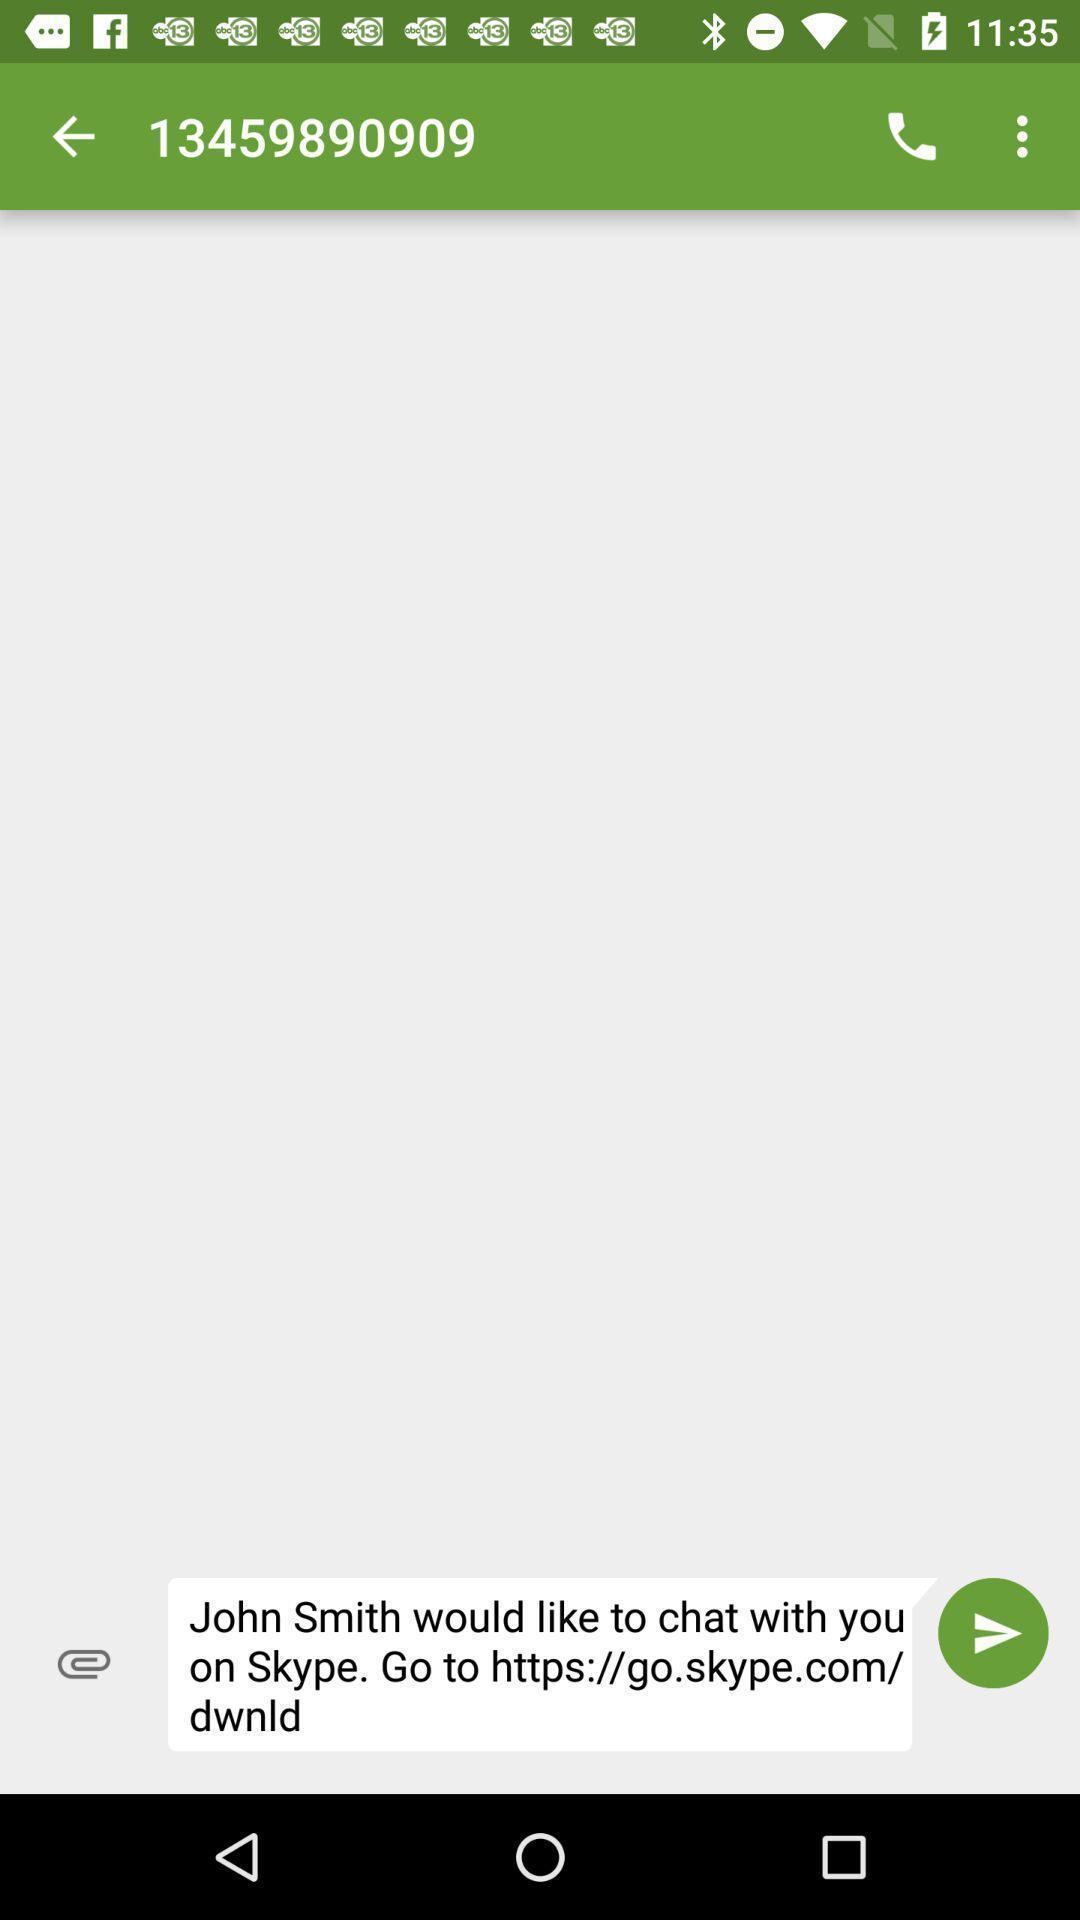Describe the visual elements of this screenshot. Page shows the users link to chat on social app. 